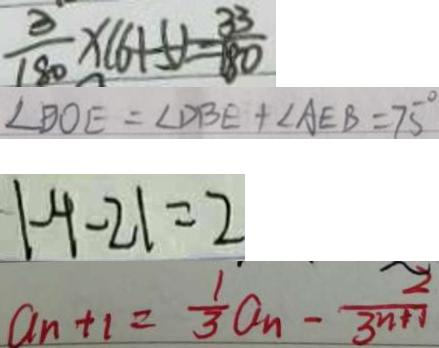Convert formula to latex. <formula><loc_0><loc_0><loc_500><loc_500>\frac { 3 } { 1 8 0 } \times ( 6 + 5 ) = \frac { 3 3 } { 1 8 0 } 
 \angle B O E = \angle D B E + \angle A E B = 7 5 ^ { \circ } 
 \vert - 4 - 2 \vert = 2 
 a _ { n + 1 } = \frac { 1 } { 3 } a _ { n } - \frac { 2 } { 3 n + 1 }</formula> 